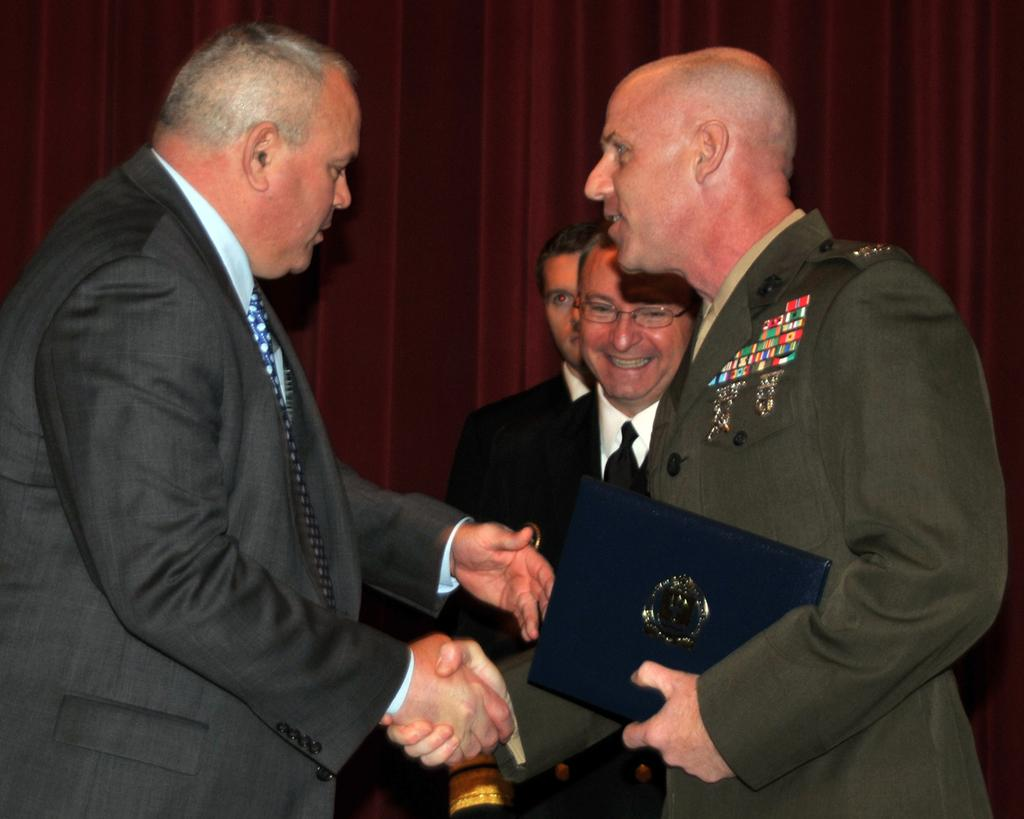How many people are present in the image? There are four people in the image. What can be observed about the clothing of the people in the image? The people are wearing different color dresses. What is one person holding in the image? One person is holding a blue object. What color is the curtain visible in the background of the image? There is a maroon curtain in the background of the image. What type of rice is being used to glue the people together in the image? There is no rice or glue present in the image, and the people are not being held together. 